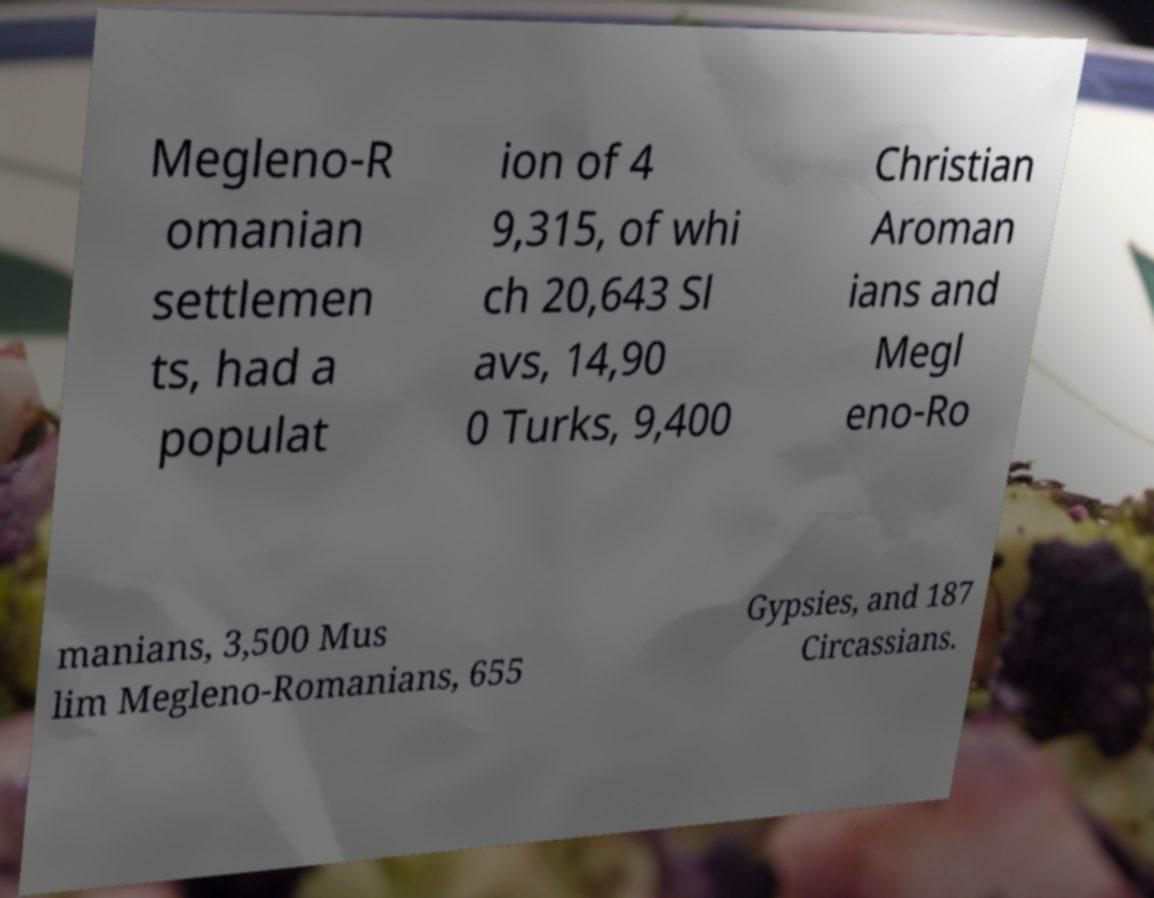Could you assist in decoding the text presented in this image and type it out clearly? Megleno-R omanian settlemen ts, had a populat ion of 4 9,315, of whi ch 20,643 Sl avs, 14,90 0 Turks, 9,400 Christian Aroman ians and Megl eno-Ro manians, 3,500 Mus lim Megleno-Romanians, 655 Gypsies, and 187 Circassians. 